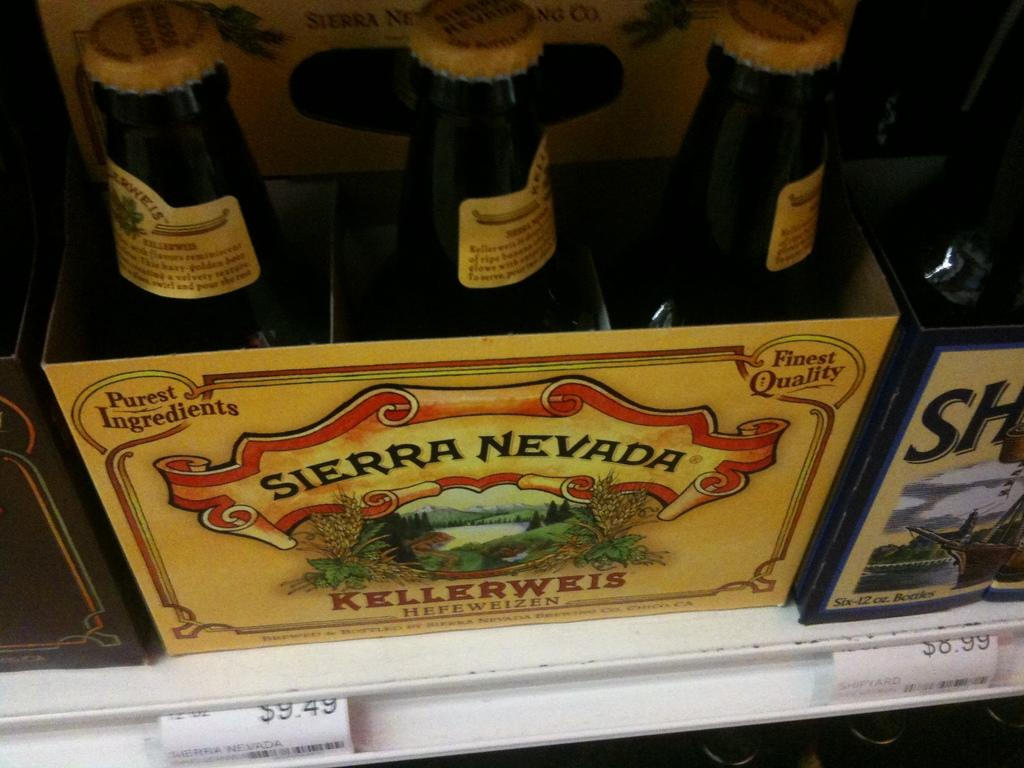<image>
Relay a brief, clear account of the picture shown. the six pack of Sierra Nevada is $9.49 